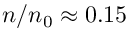Convert formula to latex. <formula><loc_0><loc_0><loc_500><loc_500>n / n _ { 0 } \approx 0 . 1 5</formula> 